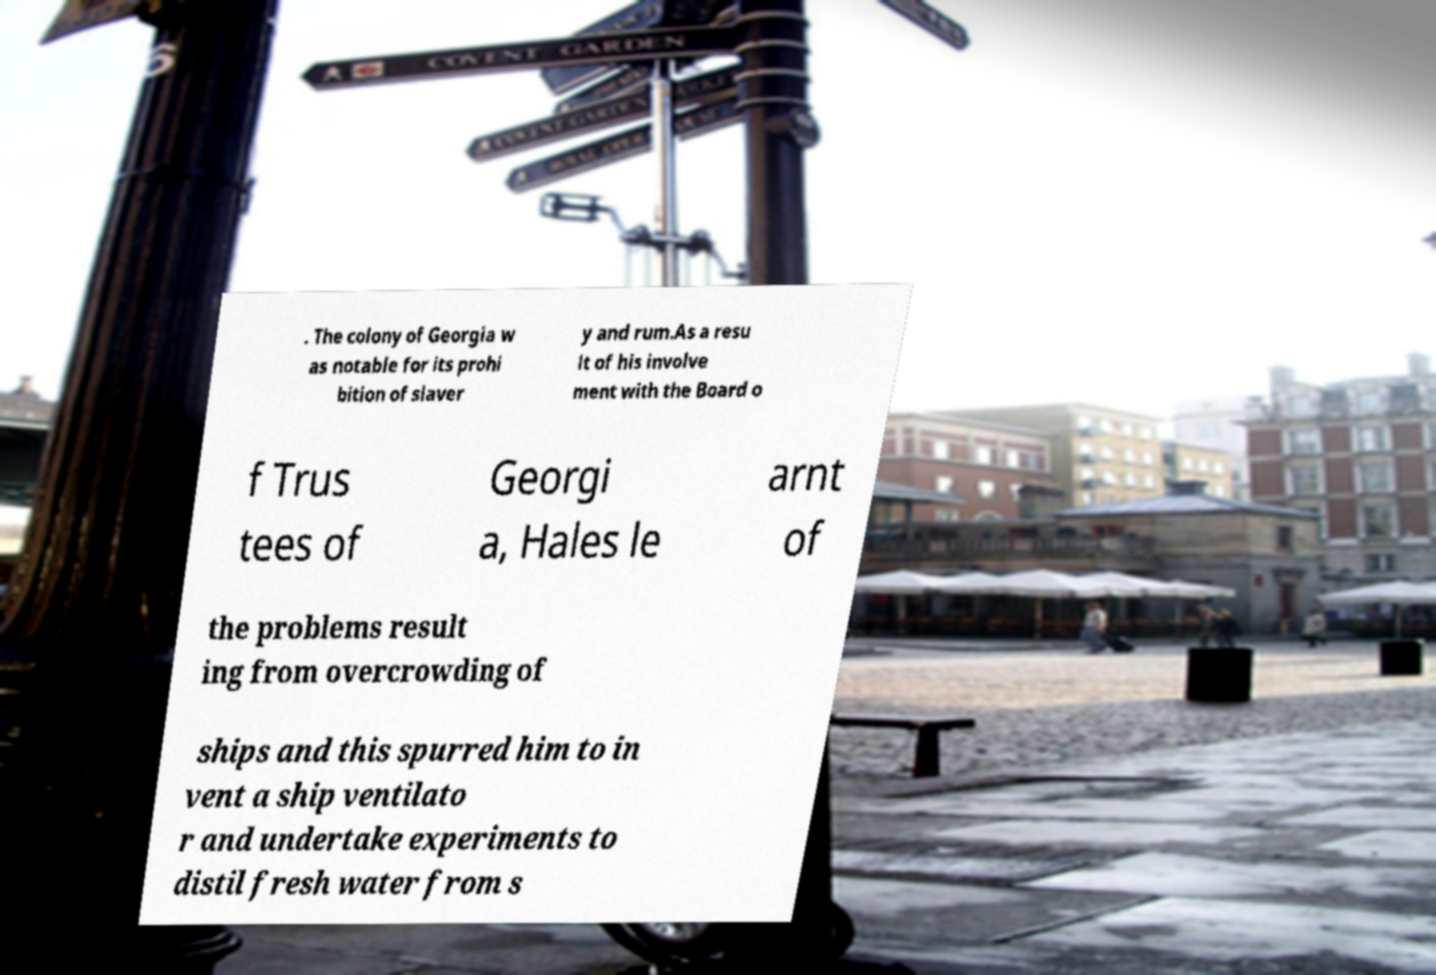For documentation purposes, I need the text within this image transcribed. Could you provide that? . The colony of Georgia w as notable for its prohi bition of slaver y and rum.As a resu lt of his involve ment with the Board o f Trus tees of Georgi a, Hales le arnt of the problems result ing from overcrowding of ships and this spurred him to in vent a ship ventilato r and undertake experiments to distil fresh water from s 